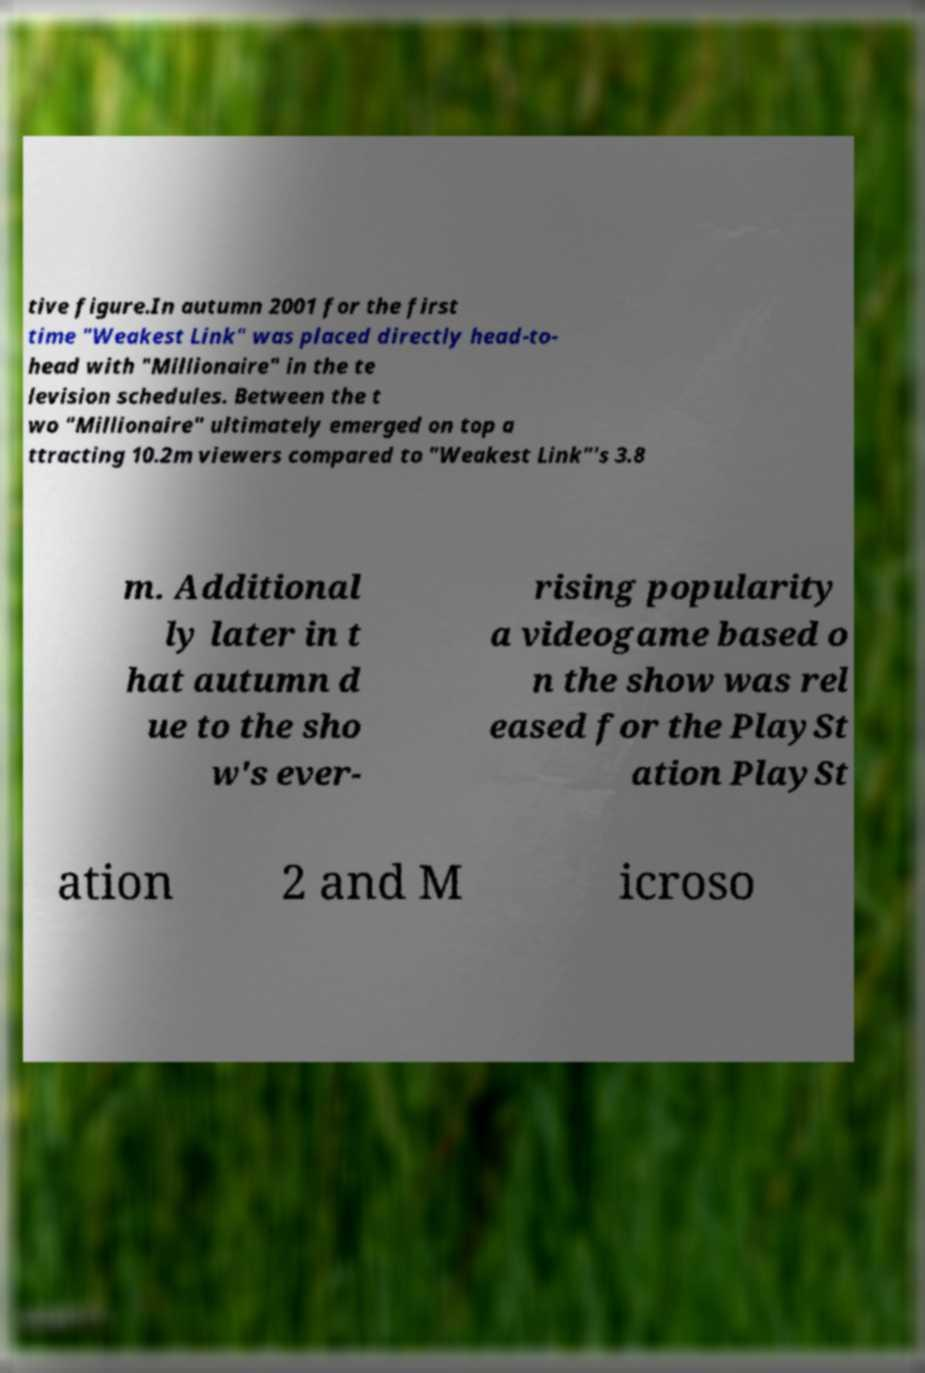Could you extract and type out the text from this image? tive figure.In autumn 2001 for the first time "Weakest Link" was placed directly head-to- head with "Millionaire" in the te levision schedules. Between the t wo "Millionaire" ultimately emerged on top a ttracting 10.2m viewers compared to "Weakest Link"'s 3.8 m. Additional ly later in t hat autumn d ue to the sho w's ever- rising popularity a videogame based o n the show was rel eased for the PlaySt ation PlaySt ation 2 and M icroso 